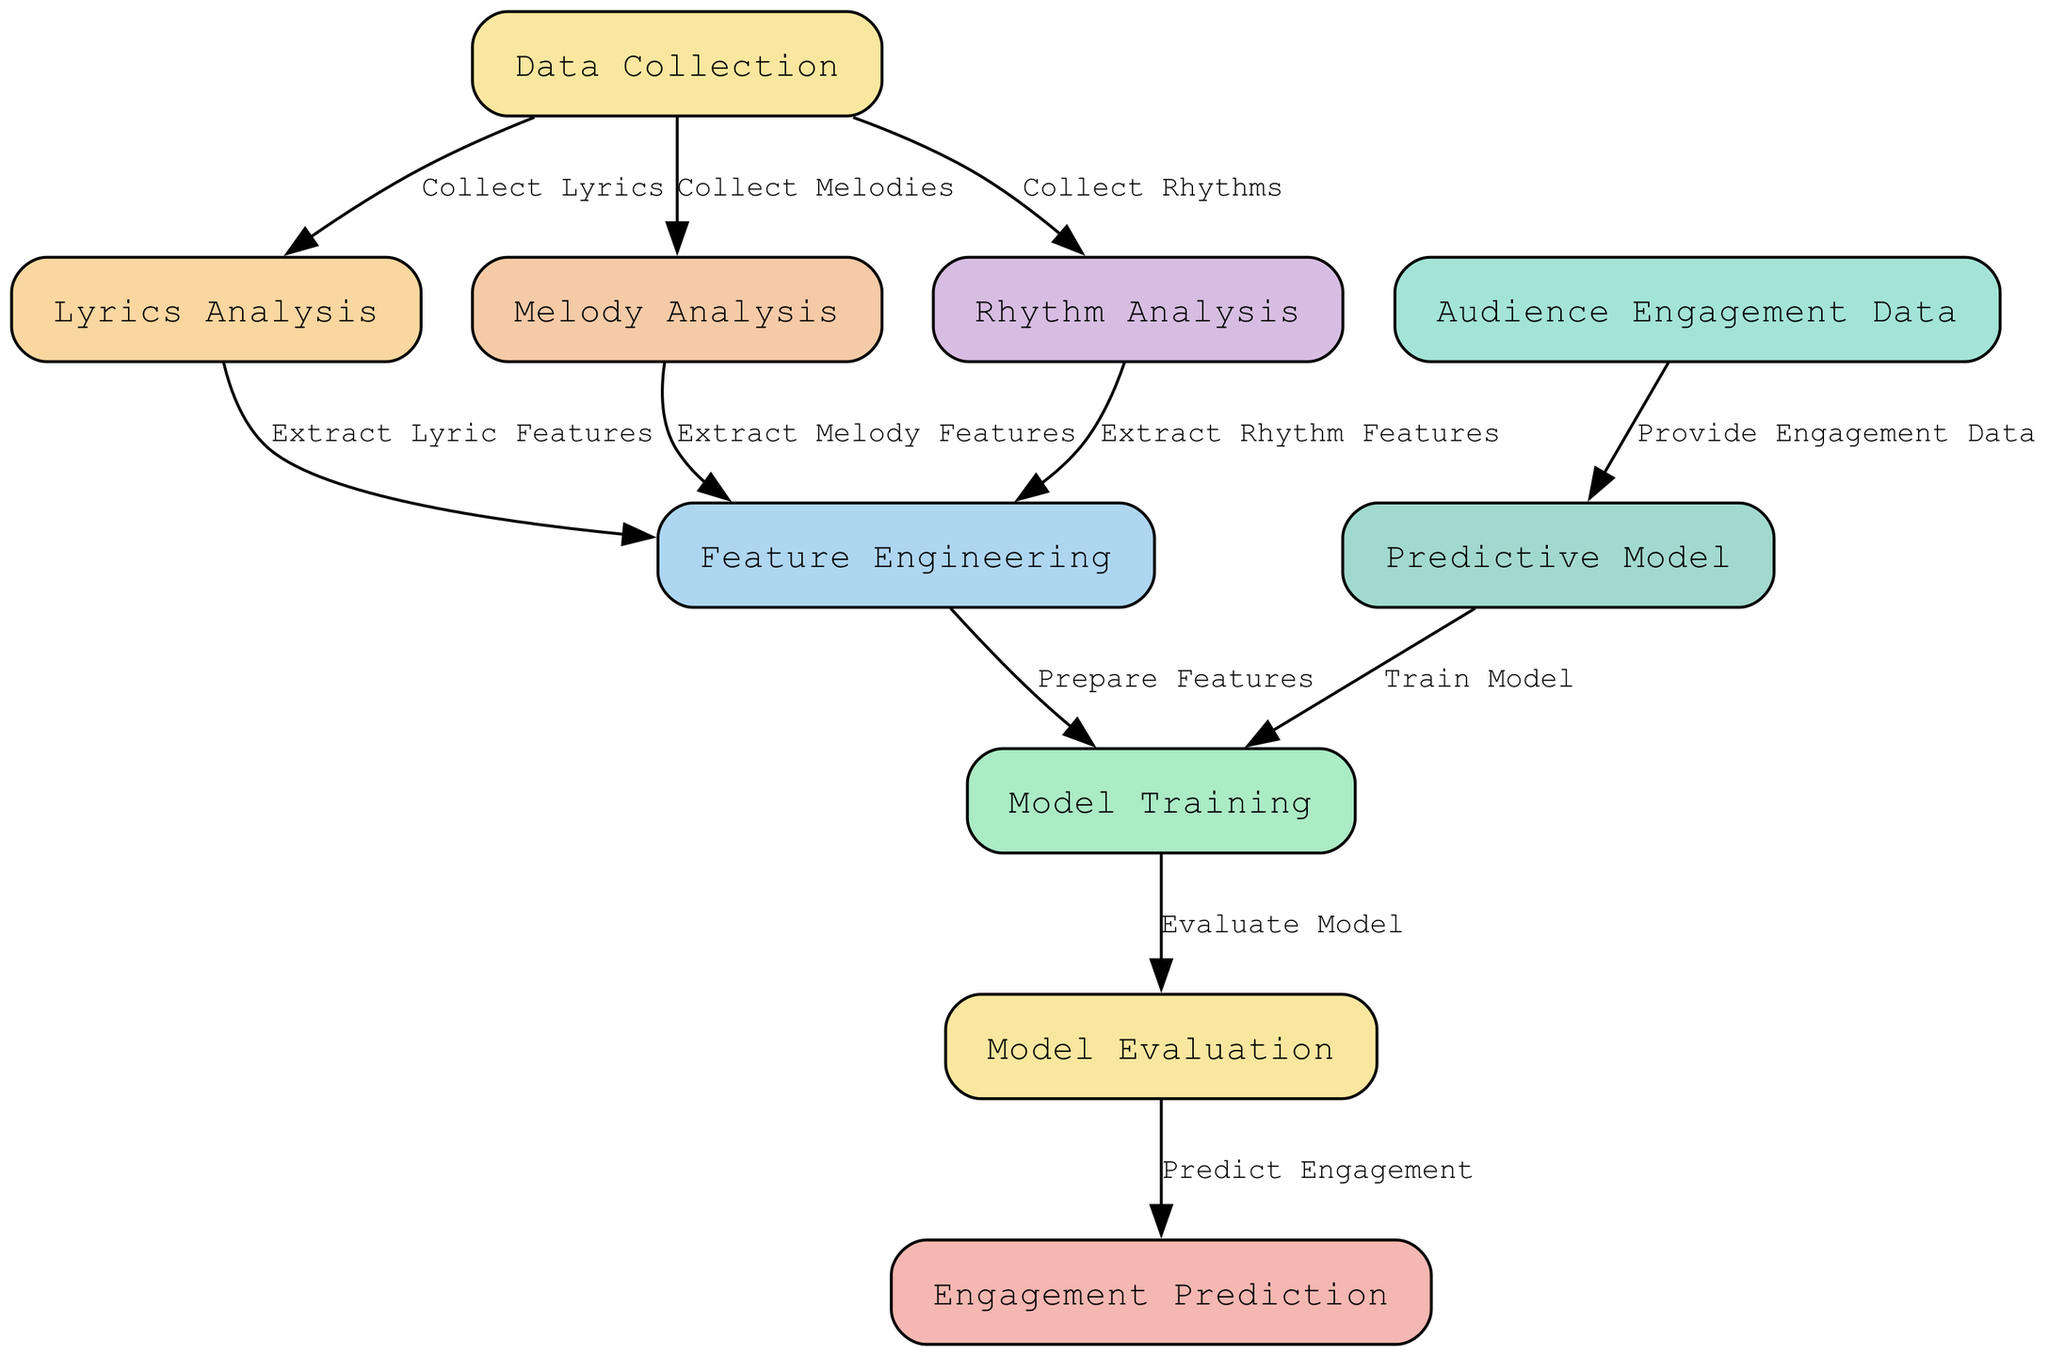What is the first step in the diagram? The first step in the diagram is "Data Collection," which is the node labeled as "1." This node initiates the entire process by gathering the necessary data such as lyrics, melodies, and rhythms.
Answer: Data Collection How many nodes are present in the diagram? The diagram contains ten nodes, each representing a distinct step in the predictive model for audience engagement. The nodes include steps from data collection to engagement prediction.
Answer: Ten What does the "Lyrics Analysis" node provide to the "Feature Engineering" node? The "Lyrics Analysis" node provides extracted lyric features to the "Feature Engineering" node, indicating that analyzed data is being utilized for creating features for the model.
Answer: Extract Lyric Features Which nodes are directly linked to "Model Training"? The "Model Training" node receives input from the "Predictive Model" node and the "Prepare Features" node, showing that both the model itself and the features need to be established prior to training.
Answer: Predictive Model, Prepare Features What is the role of the "Audience Engagement Data" node in this diagram? The "Audience Engagement Data" node provides engagement data to the "Predictive Model" node, which is essential for making predictions about audience engagement based on the collected data.
Answer: Provide Engagement Data Which node evaluates the model? The "Model Evaluation" node evaluates the model, ensuring that its performance is assessed before making any predictions about audience engagement.
Answer: Model Evaluation How does the feature engineering process integrate inputs from different analyses? The "Feature Engineering" node receives features extracted from "Lyrics Analysis," "Melody Analysis," and "Rhythm Analysis," indicating a combination of inputs from various analyses to prepare effective features for the model.
Answer: Extract Lyric Features, Extract Melody Features, Extract Rhythm Features What comes after "Model Evaluation" in the flow? After the "Model Evaluation" node, the flow proceeds to "Engagement Prediction," which utilizes the evaluated model to predict how audiences will engage with the music.
Answer: Engagement Prediction What is the second node from the "Data Collection"? The second node from "Data Collection" is "Lyrics Analysis," which focuses on analyzing the lyrics collected during the data gathering process.
Answer: Lyrics Analysis 